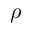<formula> <loc_0><loc_0><loc_500><loc_500>\rho</formula> 